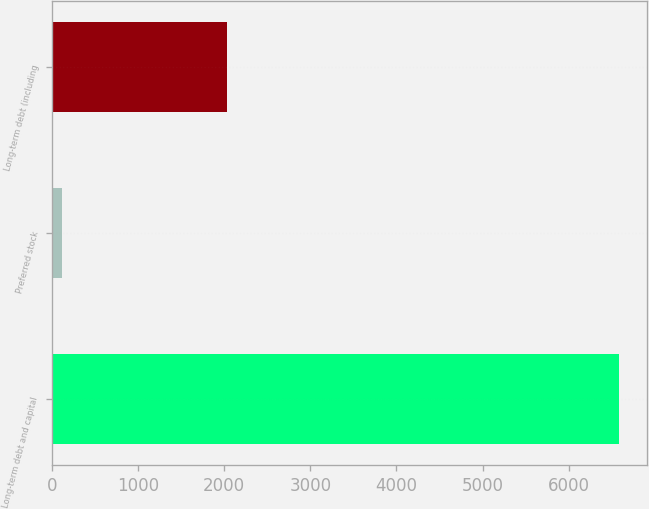<chart> <loc_0><loc_0><loc_500><loc_500><bar_chart><fcel>Long-term debt and capital<fcel>Preferred stock<fcel>Long-term debt (including<nl><fcel>6584<fcel>118<fcel>2028<nl></chart> 